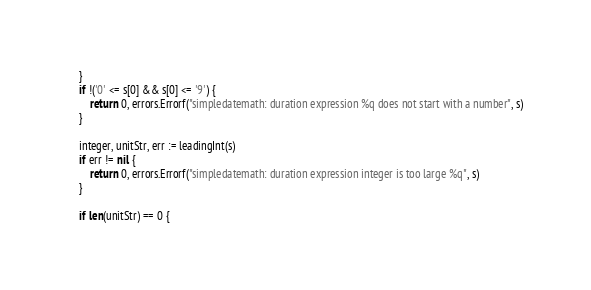<code> <loc_0><loc_0><loc_500><loc_500><_Go_>	}
	if !('0' <= s[0] && s[0] <= '9') {
		return 0, errors.Errorf("simpledatemath: duration expression %q does not start with a number", s)
	}

	integer, unitStr, err := leadingInt(s)
	if err != nil {
		return 0, errors.Errorf("simpledatemath: duration expression integer is too large %q", s)
	}

	if len(unitStr) == 0 {</code> 